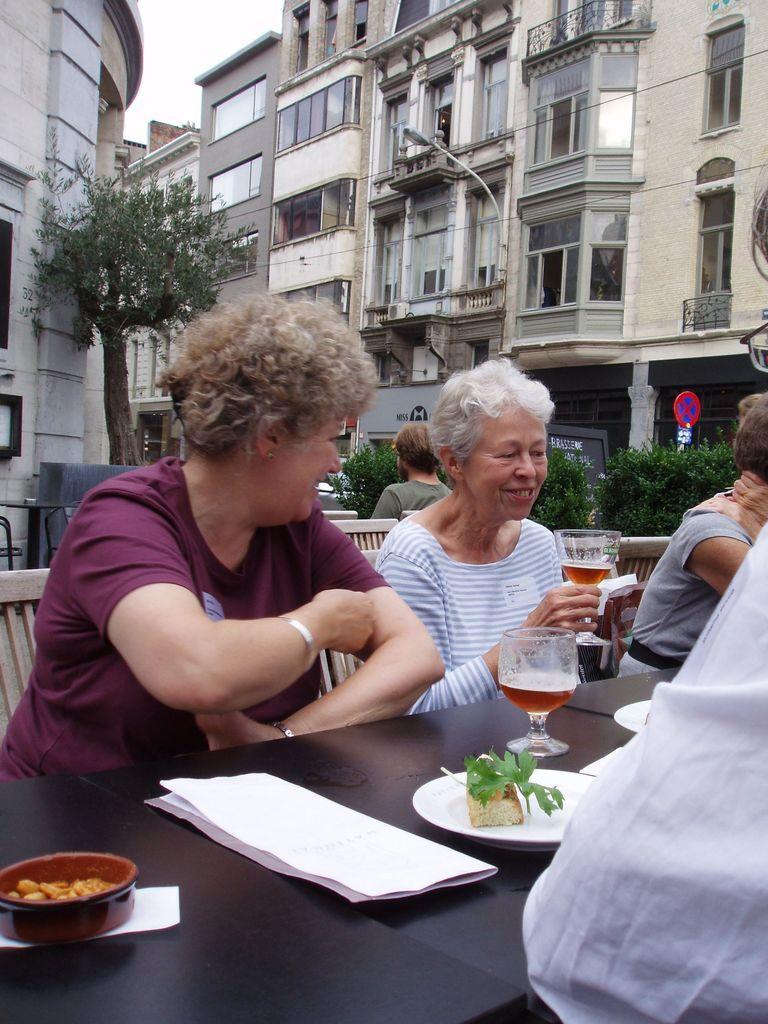Can you describe this image briefly? Here we can see two persons are sitting on the chairs. This is table. On the table there is a plate, glass, papers, and a bowl. In the background we can see buildings. These are the plants and there is a tree. And this is sky. 